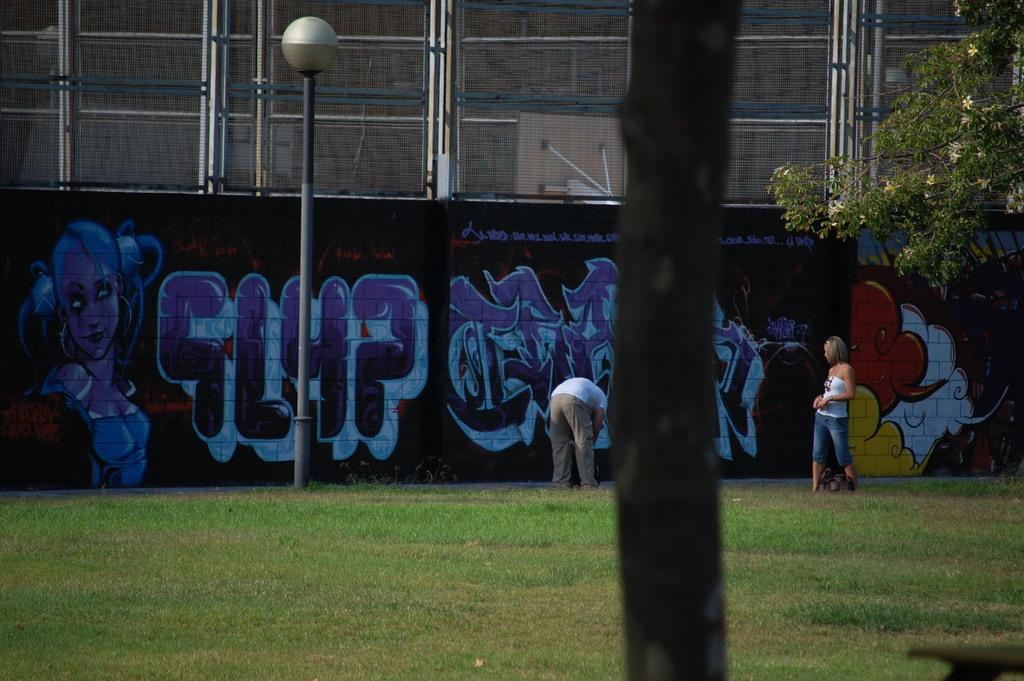What are the people in the image doing? The persons standing on the ground in the image are likely just standing or waiting. What is the purpose of the street pole in the image? The street pole in the image is likely used to hold street lights or other signs. What is the function of the street light in the image? The street light in the image provides illumination at night or in low-light conditions. What type of artwork can be seen on the wall in the image? The paintings on the wall in the image are likely decorative or artistic in nature. What is the mesh used for in the image? The mesh in the image could be used for various purposes, such as fencing, screening, or decoration. What type of plant is present in the image? There is a tree in the image, which is a type of plant. How many experts are attending the party in the image? There are no experts or parties present in the image. 